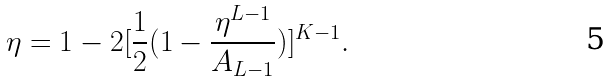Convert formula to latex. <formula><loc_0><loc_0><loc_500><loc_500>\eta = 1 - 2 [ \frac { 1 } { 2 } ( 1 - \frac { \eta ^ { L - 1 } } { A _ { L - 1 } } ) ] ^ { K - 1 } .</formula> 